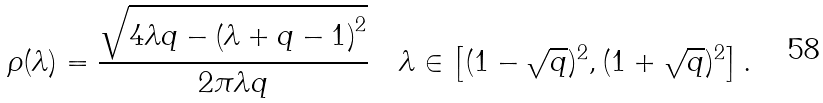<formula> <loc_0><loc_0><loc_500><loc_500>\rho ( \lambda ) = \frac { \sqrt { 4 \lambda q - \left ( \lambda + q - 1 \right ) ^ { 2 } } } { 2 \pi \lambda q } \quad \lambda \in \left [ ( 1 - \sqrt { q } ) ^ { 2 } , ( 1 + \sqrt { q } ) ^ { 2 } \right ] .</formula> 